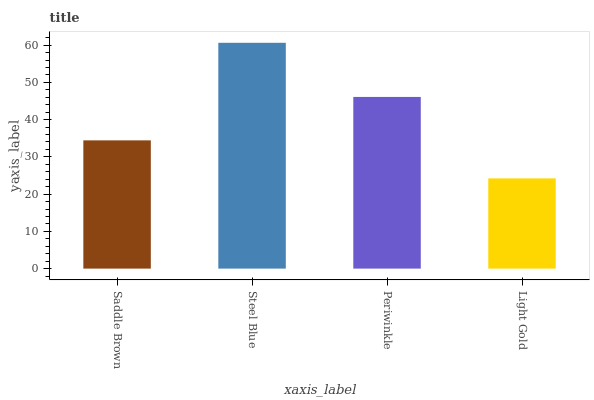Is Light Gold the minimum?
Answer yes or no. Yes. Is Steel Blue the maximum?
Answer yes or no. Yes. Is Periwinkle the minimum?
Answer yes or no. No. Is Periwinkle the maximum?
Answer yes or no. No. Is Steel Blue greater than Periwinkle?
Answer yes or no. Yes. Is Periwinkle less than Steel Blue?
Answer yes or no. Yes. Is Periwinkle greater than Steel Blue?
Answer yes or no. No. Is Steel Blue less than Periwinkle?
Answer yes or no. No. Is Periwinkle the high median?
Answer yes or no. Yes. Is Saddle Brown the low median?
Answer yes or no. Yes. Is Steel Blue the high median?
Answer yes or no. No. Is Light Gold the low median?
Answer yes or no. No. 